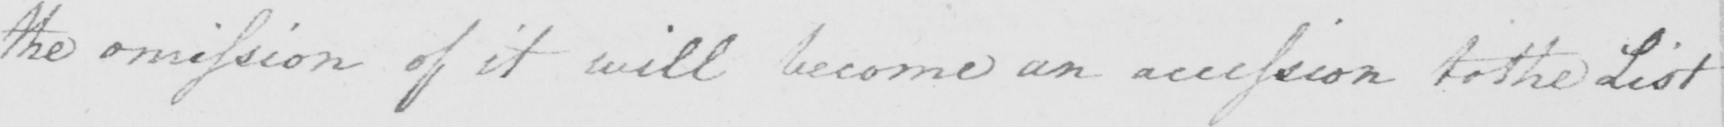Please provide the text content of this handwritten line. the omission of it will become an accession to the List 